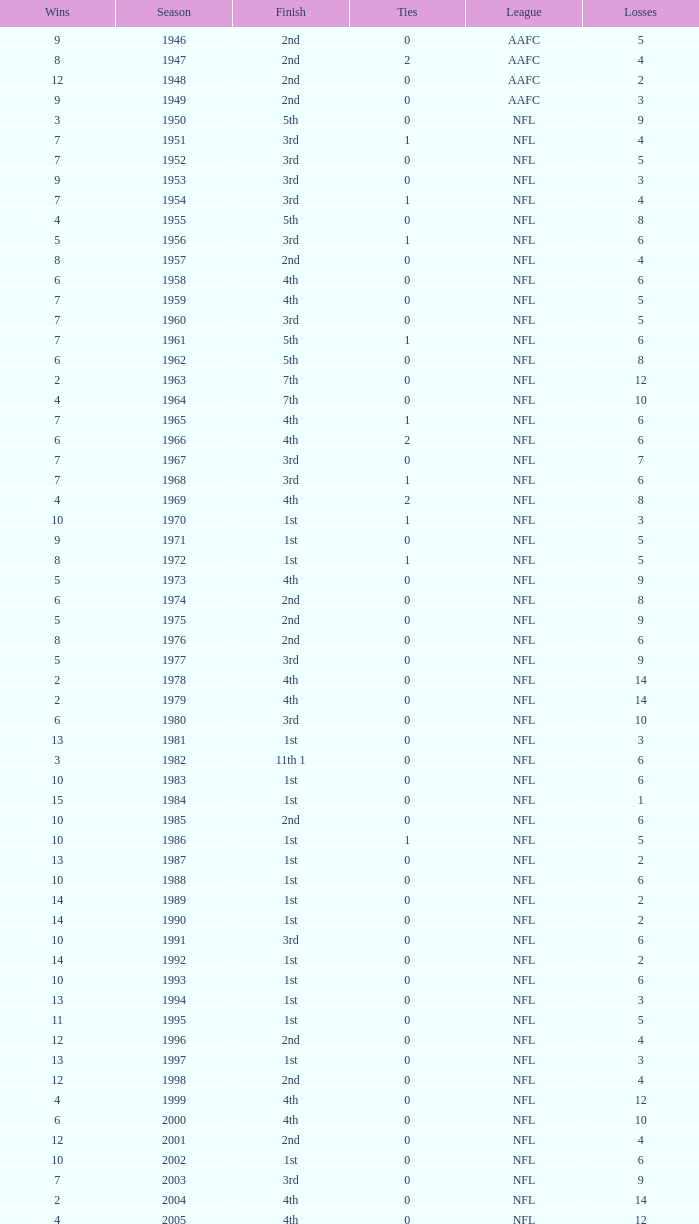What is the lowest number of ties in the NFL, with less than 2 losses and less than 15 wins? None. 